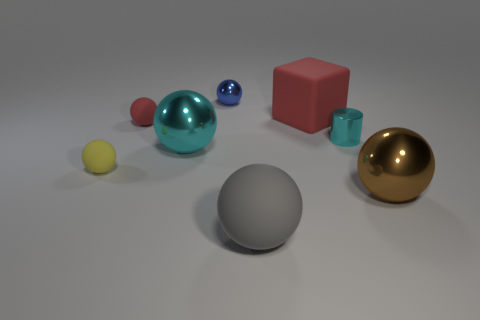Subtract 2 spheres. How many spheres are left? 4 Subtract all blue spheres. How many spheres are left? 5 Subtract all tiny yellow balls. How many balls are left? 5 Subtract all purple balls. Subtract all red cylinders. How many balls are left? 6 Subtract all balls. How many objects are left? 2 Subtract all big brown balls. Subtract all large cyan shiny balls. How many objects are left? 6 Add 2 tiny metallic things. How many tiny metallic things are left? 4 Add 7 cyan shiny cylinders. How many cyan shiny cylinders exist? 8 Subtract 1 cyan spheres. How many objects are left? 7 